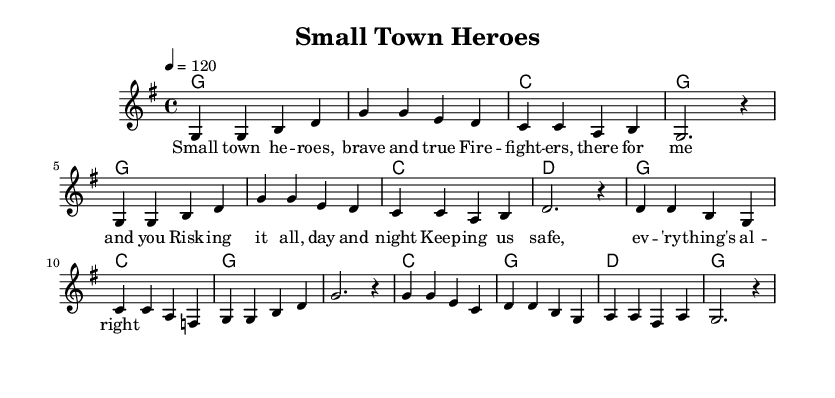What is the key signature of this music? The key signature is G major, which has one sharp (F#). This can be identified by looking at the key signature at the beginning of the staff.
Answer: G major What is the time signature of this piece? The time signature is 4/4, meaning there are four beats in each measure and a quarter note receives one beat. This information is indicated at the start of the music.
Answer: 4/4 What is the tempo marking for this piece? The tempo marking is 120 beats per minute, indicated by the instruction "4 = 120" at the beginning of the score. This tells musicians how fast to play the piece.
Answer: 120 How many measures are in the melody? The melody consists of 8 measures. This can be counted by noting the divisions between the bar lines in the melody notation.
Answer: 8 What is the first note of the melody? The first note of the melody is G. It can be identified by looking at the first note placed on the staff in the melody section.
Answer: G How many different chords are used in the harmonies section? There are 4 different chords used: G, C, D, and an emphasized G. These can be noted by observing the different chord symbols written above the melody.
Answer: 4 What theme do the lyrics convey? The lyrics celebrate firefighter heroes in a small town, emphasizing bravery and safety. This theme can be gathered from reading the lyrics written beneath the melody notes.
Answer: Firefighter heroes 